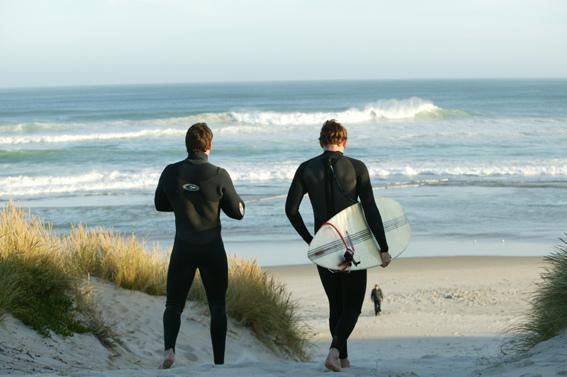How many men in this scene?
Give a very brief answer. 2. How many people can you see?
Give a very brief answer. 2. How many surfboards are there?
Give a very brief answer. 1. How many colorful umbrellas are there?
Give a very brief answer. 0. 